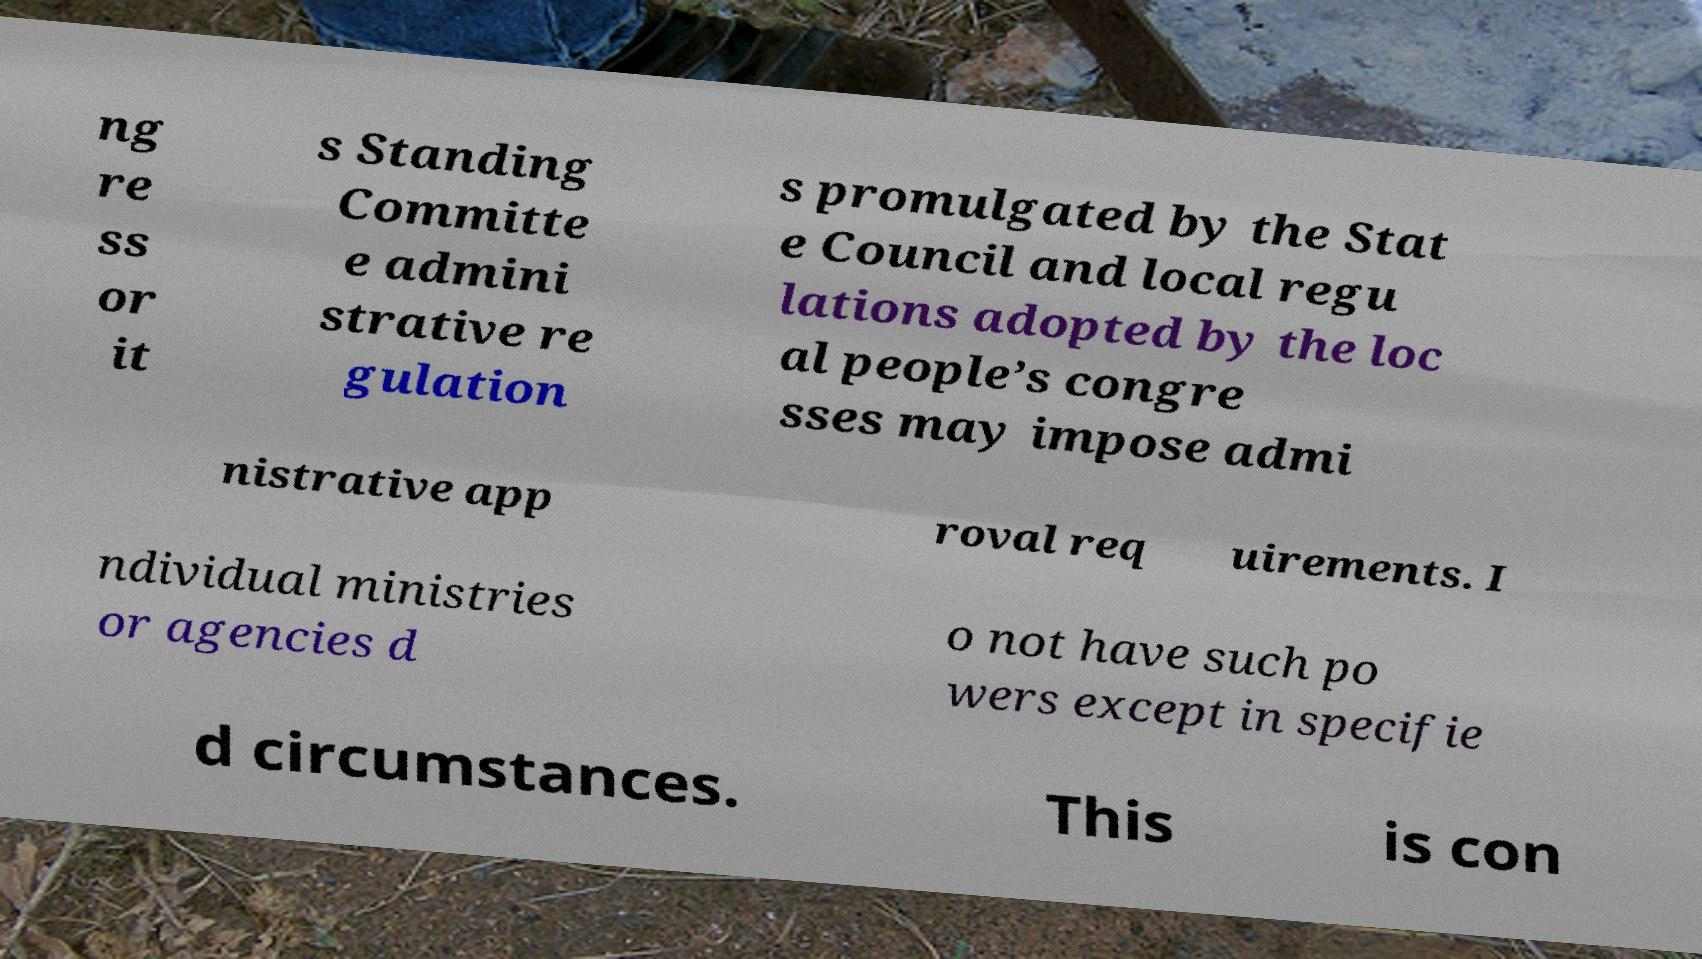I need the written content from this picture converted into text. Can you do that? ng re ss or it s Standing Committe e admini strative re gulation s promulgated by the Stat e Council and local regu lations adopted by the loc al people’s congre sses may impose admi nistrative app roval req uirements. I ndividual ministries or agencies d o not have such po wers except in specifie d circumstances. This is con 